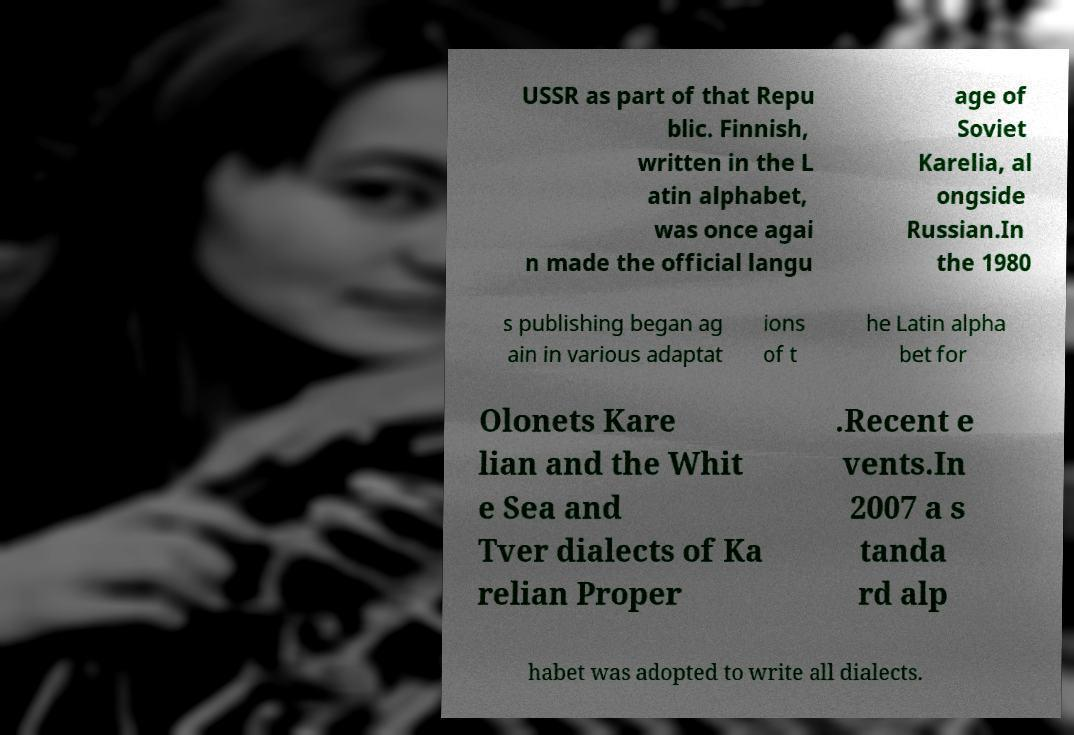What messages or text are displayed in this image? I need them in a readable, typed format. USSR as part of that Repu blic. Finnish, written in the L atin alphabet, was once agai n made the official langu age of Soviet Karelia, al ongside Russian.In the 1980 s publishing began ag ain in various adaptat ions of t he Latin alpha bet for Olonets Kare lian and the Whit e Sea and Tver dialects of Ka relian Proper .Recent e vents.In 2007 a s tanda rd alp habet was adopted to write all dialects. 